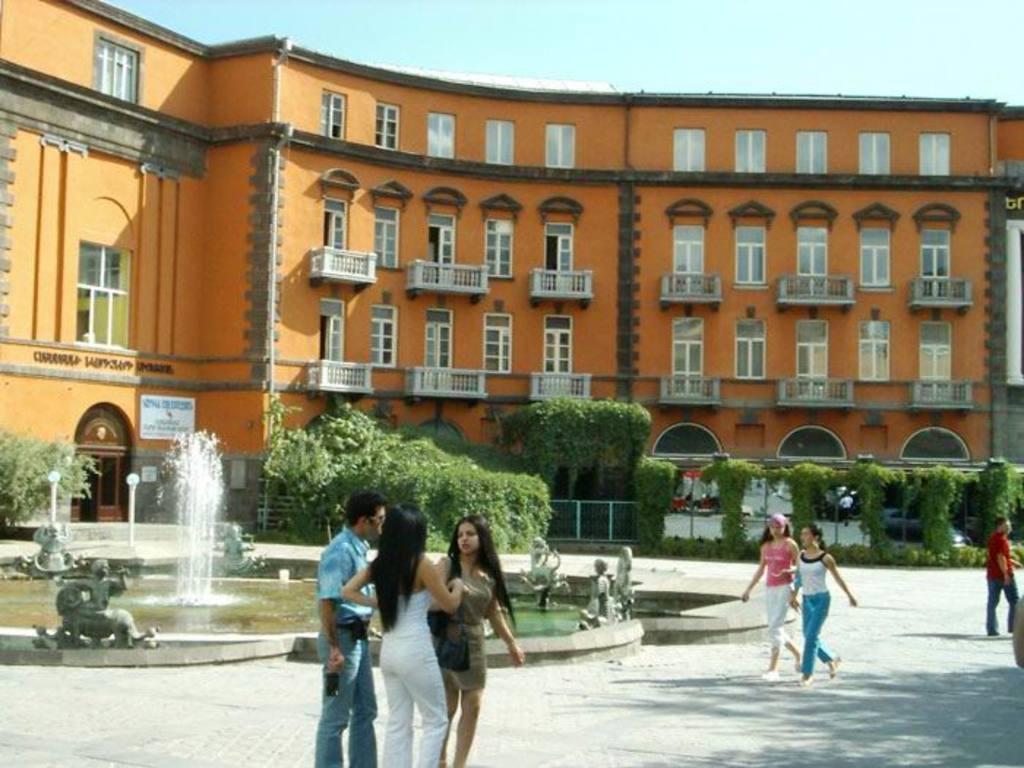Could you give a brief overview of what you see in this image? This image consists of many people walking and standing. In the middle, there is a fountain. In the background, we can see a building along with windows. In the front, there are trees and plants. At the top, there is sky. 